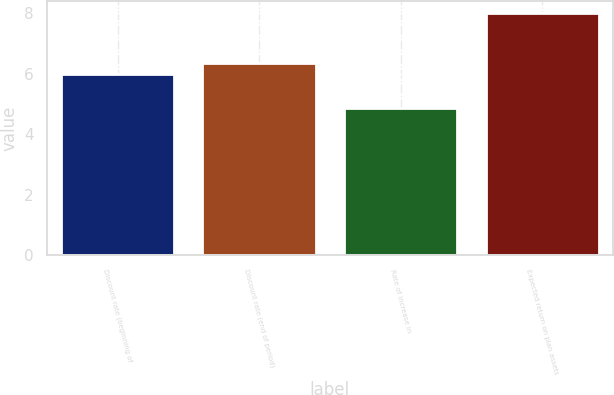Convert chart. <chart><loc_0><loc_0><loc_500><loc_500><bar_chart><fcel>Discount rate (beginning of<fcel>Discount rate (end of period)<fcel>Rate of increase in<fcel>Expected return on plan assets<nl><fcel>6<fcel>6.35<fcel>4.85<fcel>8<nl></chart> 